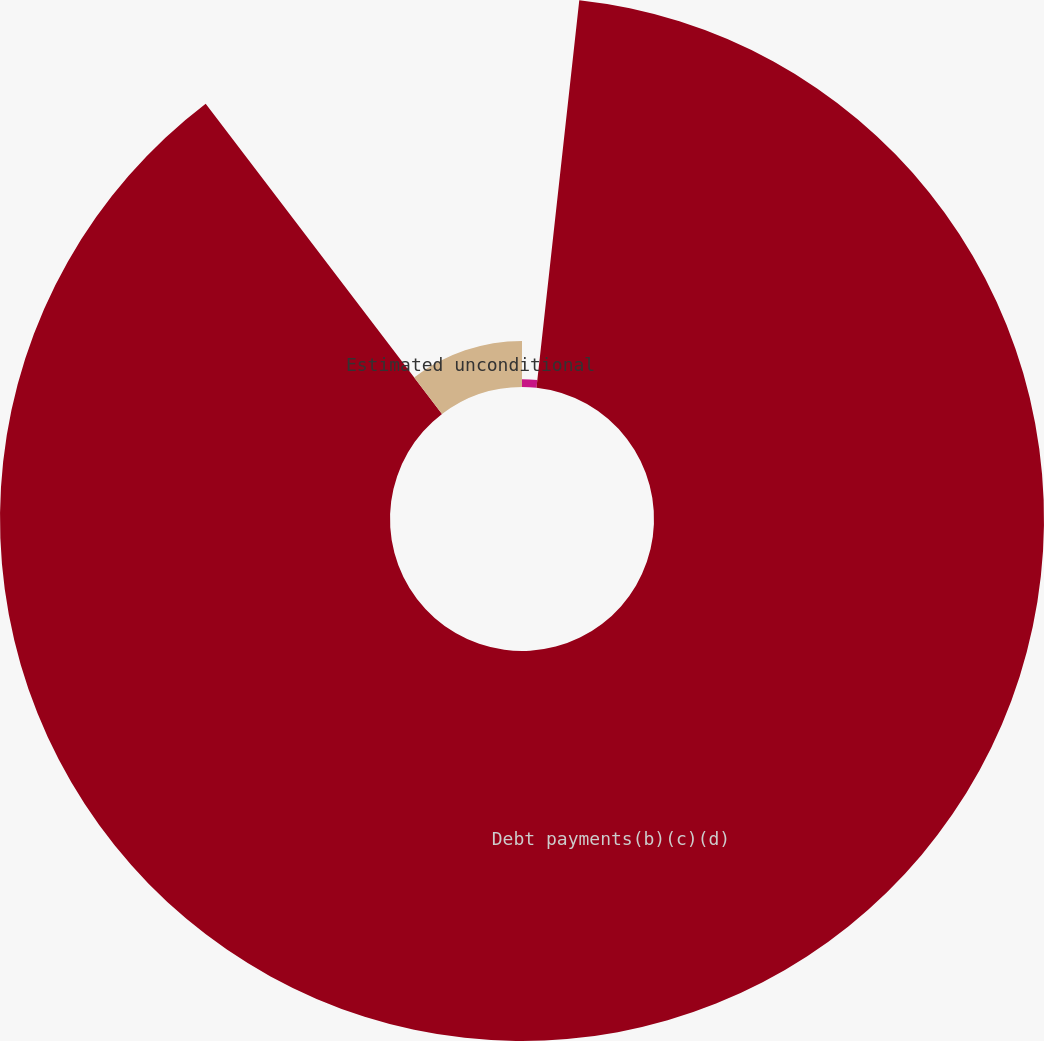Convert chart to OTSL. <chart><loc_0><loc_0><loc_500><loc_500><pie_chart><fcel>Environmental remediation<fcel>Debt payments(b)(c)(d)<fcel>Estimated unconditional<nl><fcel>1.75%<fcel>87.88%<fcel>10.36%<nl></chart> 